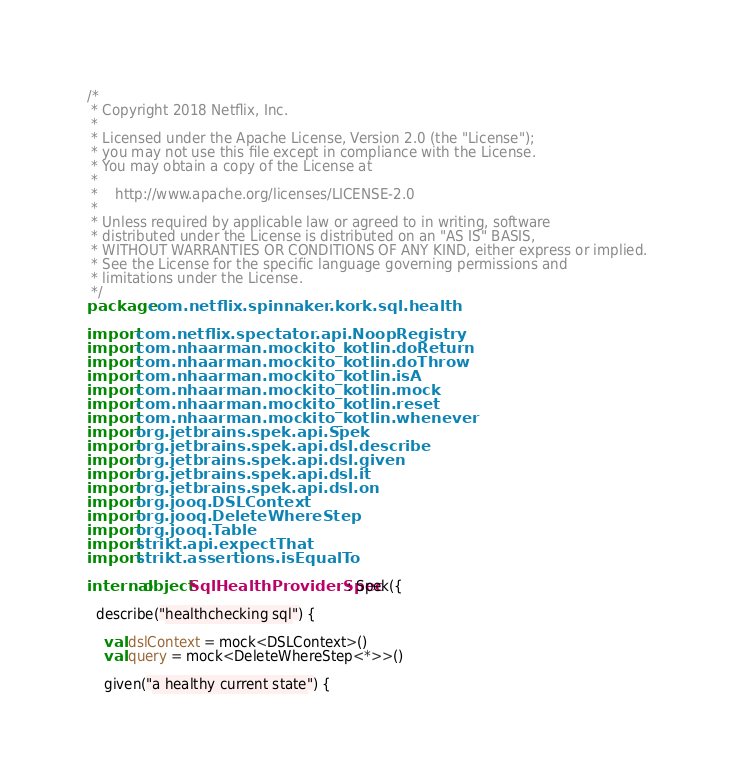<code> <loc_0><loc_0><loc_500><loc_500><_Kotlin_>/*
 * Copyright 2018 Netflix, Inc.
 *
 * Licensed under the Apache License, Version 2.0 (the "License");
 * you may not use this file except in compliance with the License.
 * You may obtain a copy of the License at
 *
 *    http://www.apache.org/licenses/LICENSE-2.0
 *
 * Unless required by applicable law or agreed to in writing, software
 * distributed under the License is distributed on an "AS IS" BASIS,
 * WITHOUT WARRANTIES OR CONDITIONS OF ANY KIND, either express or implied.
 * See the License for the specific language governing permissions and
 * limitations under the License.
 */
package com.netflix.spinnaker.kork.sql.health

import com.netflix.spectator.api.NoopRegistry
import com.nhaarman.mockito_kotlin.doReturn
import com.nhaarman.mockito_kotlin.doThrow
import com.nhaarman.mockito_kotlin.isA
import com.nhaarman.mockito_kotlin.mock
import com.nhaarman.mockito_kotlin.reset
import com.nhaarman.mockito_kotlin.whenever
import org.jetbrains.spek.api.Spek
import org.jetbrains.spek.api.dsl.describe
import org.jetbrains.spek.api.dsl.given
import org.jetbrains.spek.api.dsl.it
import org.jetbrains.spek.api.dsl.on
import org.jooq.DSLContext
import org.jooq.DeleteWhereStep
import org.jooq.Table
import strikt.api.expectThat
import strikt.assertions.isEqualTo

internal object SqlHealthProviderSpec : Spek({

  describe("healthchecking sql") {

    val dslContext = mock<DSLContext>()
    val query = mock<DeleteWhereStep<*>>()

    given("a healthy current state") {</code> 